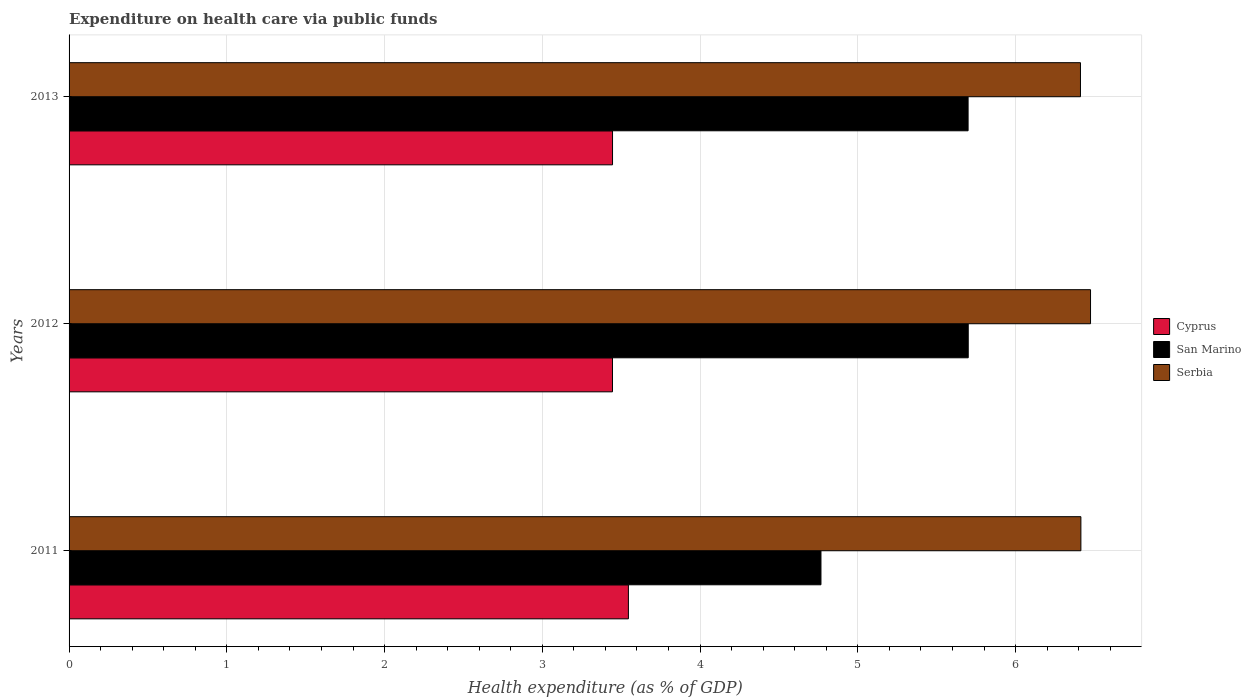How many different coloured bars are there?
Make the answer very short. 3. Are the number of bars per tick equal to the number of legend labels?
Provide a succinct answer. Yes. Are the number of bars on each tick of the Y-axis equal?
Ensure brevity in your answer.  Yes. How many bars are there on the 2nd tick from the top?
Offer a terse response. 3. How many bars are there on the 1st tick from the bottom?
Ensure brevity in your answer.  3. What is the label of the 1st group of bars from the top?
Offer a very short reply. 2013. In how many cases, is the number of bars for a given year not equal to the number of legend labels?
Ensure brevity in your answer.  0. What is the expenditure made on health care in San Marino in 2013?
Your answer should be very brief. 5.7. Across all years, what is the maximum expenditure made on health care in Cyprus?
Ensure brevity in your answer.  3.55. Across all years, what is the minimum expenditure made on health care in Serbia?
Make the answer very short. 6.41. In which year was the expenditure made on health care in Serbia minimum?
Offer a terse response. 2013. What is the total expenditure made on health care in Cyprus in the graph?
Keep it short and to the point. 10.44. What is the difference between the expenditure made on health care in Serbia in 2011 and that in 2012?
Make the answer very short. -0.06. What is the difference between the expenditure made on health care in Cyprus in 2013 and the expenditure made on health care in Serbia in 2012?
Your response must be concise. -3.03. What is the average expenditure made on health care in Serbia per year?
Provide a succinct answer. 6.43. In the year 2011, what is the difference between the expenditure made on health care in Serbia and expenditure made on health care in San Marino?
Your answer should be very brief. 1.65. In how many years, is the expenditure made on health care in Cyprus greater than 1.2 %?
Your answer should be very brief. 3. What is the ratio of the expenditure made on health care in Cyprus in 2011 to that in 2012?
Ensure brevity in your answer.  1.03. Is the expenditure made on health care in Serbia in 2011 less than that in 2013?
Your response must be concise. No. What is the difference between the highest and the second highest expenditure made on health care in San Marino?
Provide a short and direct response. 0. What is the difference between the highest and the lowest expenditure made on health care in Cyprus?
Offer a very short reply. 0.1. In how many years, is the expenditure made on health care in San Marino greater than the average expenditure made on health care in San Marino taken over all years?
Ensure brevity in your answer.  2. What does the 3rd bar from the top in 2012 represents?
Give a very brief answer. Cyprus. What does the 2nd bar from the bottom in 2012 represents?
Ensure brevity in your answer.  San Marino. Are all the bars in the graph horizontal?
Give a very brief answer. Yes. What is the difference between two consecutive major ticks on the X-axis?
Your response must be concise. 1. Are the values on the major ticks of X-axis written in scientific E-notation?
Your response must be concise. No. Where does the legend appear in the graph?
Provide a succinct answer. Center right. How many legend labels are there?
Your answer should be very brief. 3. How are the legend labels stacked?
Make the answer very short. Vertical. What is the title of the graph?
Provide a short and direct response. Expenditure on health care via public funds. Does "Samoa" appear as one of the legend labels in the graph?
Make the answer very short. No. What is the label or title of the X-axis?
Your answer should be compact. Health expenditure (as % of GDP). What is the Health expenditure (as % of GDP) in Cyprus in 2011?
Offer a very short reply. 3.55. What is the Health expenditure (as % of GDP) in San Marino in 2011?
Your answer should be compact. 4.77. What is the Health expenditure (as % of GDP) in Serbia in 2011?
Provide a succinct answer. 6.41. What is the Health expenditure (as % of GDP) of Cyprus in 2012?
Give a very brief answer. 3.44. What is the Health expenditure (as % of GDP) of San Marino in 2012?
Provide a short and direct response. 5.7. What is the Health expenditure (as % of GDP) of Serbia in 2012?
Give a very brief answer. 6.48. What is the Health expenditure (as % of GDP) of Cyprus in 2013?
Offer a terse response. 3.45. What is the Health expenditure (as % of GDP) in San Marino in 2013?
Offer a very short reply. 5.7. What is the Health expenditure (as % of GDP) in Serbia in 2013?
Keep it short and to the point. 6.41. Across all years, what is the maximum Health expenditure (as % of GDP) of Cyprus?
Provide a short and direct response. 3.55. Across all years, what is the maximum Health expenditure (as % of GDP) of San Marino?
Give a very brief answer. 5.7. Across all years, what is the maximum Health expenditure (as % of GDP) of Serbia?
Provide a short and direct response. 6.48. Across all years, what is the minimum Health expenditure (as % of GDP) of Cyprus?
Your response must be concise. 3.44. Across all years, what is the minimum Health expenditure (as % of GDP) of San Marino?
Give a very brief answer. 4.77. Across all years, what is the minimum Health expenditure (as % of GDP) in Serbia?
Your response must be concise. 6.41. What is the total Health expenditure (as % of GDP) in Cyprus in the graph?
Offer a very short reply. 10.44. What is the total Health expenditure (as % of GDP) in San Marino in the graph?
Provide a short and direct response. 16.17. What is the total Health expenditure (as % of GDP) of Serbia in the graph?
Offer a very short reply. 19.3. What is the difference between the Health expenditure (as % of GDP) in Cyprus in 2011 and that in 2012?
Give a very brief answer. 0.1. What is the difference between the Health expenditure (as % of GDP) of San Marino in 2011 and that in 2012?
Your answer should be very brief. -0.93. What is the difference between the Health expenditure (as % of GDP) of Serbia in 2011 and that in 2012?
Make the answer very short. -0.06. What is the difference between the Health expenditure (as % of GDP) of Cyprus in 2011 and that in 2013?
Your response must be concise. 0.1. What is the difference between the Health expenditure (as % of GDP) in San Marino in 2011 and that in 2013?
Make the answer very short. -0.93. What is the difference between the Health expenditure (as % of GDP) in Serbia in 2011 and that in 2013?
Offer a very short reply. 0. What is the difference between the Health expenditure (as % of GDP) in Cyprus in 2012 and that in 2013?
Your answer should be very brief. -0. What is the difference between the Health expenditure (as % of GDP) of San Marino in 2012 and that in 2013?
Provide a short and direct response. 0. What is the difference between the Health expenditure (as % of GDP) in Serbia in 2012 and that in 2013?
Your answer should be very brief. 0.06. What is the difference between the Health expenditure (as % of GDP) in Cyprus in 2011 and the Health expenditure (as % of GDP) in San Marino in 2012?
Make the answer very short. -2.15. What is the difference between the Health expenditure (as % of GDP) in Cyprus in 2011 and the Health expenditure (as % of GDP) in Serbia in 2012?
Your response must be concise. -2.93. What is the difference between the Health expenditure (as % of GDP) of San Marino in 2011 and the Health expenditure (as % of GDP) of Serbia in 2012?
Ensure brevity in your answer.  -1.71. What is the difference between the Health expenditure (as % of GDP) of Cyprus in 2011 and the Health expenditure (as % of GDP) of San Marino in 2013?
Make the answer very short. -2.15. What is the difference between the Health expenditure (as % of GDP) in Cyprus in 2011 and the Health expenditure (as % of GDP) in Serbia in 2013?
Make the answer very short. -2.87. What is the difference between the Health expenditure (as % of GDP) of San Marino in 2011 and the Health expenditure (as % of GDP) of Serbia in 2013?
Offer a terse response. -1.65. What is the difference between the Health expenditure (as % of GDP) in Cyprus in 2012 and the Health expenditure (as % of GDP) in San Marino in 2013?
Provide a short and direct response. -2.25. What is the difference between the Health expenditure (as % of GDP) in Cyprus in 2012 and the Health expenditure (as % of GDP) in Serbia in 2013?
Your answer should be very brief. -2.97. What is the difference between the Health expenditure (as % of GDP) of San Marino in 2012 and the Health expenditure (as % of GDP) of Serbia in 2013?
Provide a short and direct response. -0.71. What is the average Health expenditure (as % of GDP) in Cyprus per year?
Keep it short and to the point. 3.48. What is the average Health expenditure (as % of GDP) of San Marino per year?
Ensure brevity in your answer.  5.39. What is the average Health expenditure (as % of GDP) of Serbia per year?
Make the answer very short. 6.43. In the year 2011, what is the difference between the Health expenditure (as % of GDP) of Cyprus and Health expenditure (as % of GDP) of San Marino?
Your answer should be compact. -1.22. In the year 2011, what is the difference between the Health expenditure (as % of GDP) of Cyprus and Health expenditure (as % of GDP) of Serbia?
Offer a terse response. -2.87. In the year 2011, what is the difference between the Health expenditure (as % of GDP) in San Marino and Health expenditure (as % of GDP) in Serbia?
Your response must be concise. -1.65. In the year 2012, what is the difference between the Health expenditure (as % of GDP) in Cyprus and Health expenditure (as % of GDP) in San Marino?
Make the answer very short. -2.26. In the year 2012, what is the difference between the Health expenditure (as % of GDP) of Cyprus and Health expenditure (as % of GDP) of Serbia?
Make the answer very short. -3.03. In the year 2012, what is the difference between the Health expenditure (as % of GDP) of San Marino and Health expenditure (as % of GDP) of Serbia?
Provide a succinct answer. -0.78. In the year 2013, what is the difference between the Health expenditure (as % of GDP) of Cyprus and Health expenditure (as % of GDP) of San Marino?
Your response must be concise. -2.25. In the year 2013, what is the difference between the Health expenditure (as % of GDP) in Cyprus and Health expenditure (as % of GDP) in Serbia?
Provide a short and direct response. -2.97. In the year 2013, what is the difference between the Health expenditure (as % of GDP) in San Marino and Health expenditure (as % of GDP) in Serbia?
Give a very brief answer. -0.71. What is the ratio of the Health expenditure (as % of GDP) of Cyprus in 2011 to that in 2012?
Your answer should be compact. 1.03. What is the ratio of the Health expenditure (as % of GDP) of San Marino in 2011 to that in 2012?
Give a very brief answer. 0.84. What is the ratio of the Health expenditure (as % of GDP) of Serbia in 2011 to that in 2012?
Offer a very short reply. 0.99. What is the ratio of the Health expenditure (as % of GDP) of Cyprus in 2011 to that in 2013?
Make the answer very short. 1.03. What is the ratio of the Health expenditure (as % of GDP) in San Marino in 2011 to that in 2013?
Offer a very short reply. 0.84. What is the ratio of the Health expenditure (as % of GDP) of Serbia in 2011 to that in 2013?
Provide a short and direct response. 1. What is the ratio of the Health expenditure (as % of GDP) of San Marino in 2012 to that in 2013?
Your answer should be very brief. 1. What is the ratio of the Health expenditure (as % of GDP) of Serbia in 2012 to that in 2013?
Give a very brief answer. 1.01. What is the difference between the highest and the second highest Health expenditure (as % of GDP) in Cyprus?
Your answer should be compact. 0.1. What is the difference between the highest and the second highest Health expenditure (as % of GDP) of San Marino?
Provide a short and direct response. 0. What is the difference between the highest and the second highest Health expenditure (as % of GDP) of Serbia?
Make the answer very short. 0.06. What is the difference between the highest and the lowest Health expenditure (as % of GDP) in Cyprus?
Offer a very short reply. 0.1. What is the difference between the highest and the lowest Health expenditure (as % of GDP) in San Marino?
Offer a terse response. 0.93. What is the difference between the highest and the lowest Health expenditure (as % of GDP) of Serbia?
Provide a succinct answer. 0.06. 